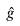Convert formula to latex. <formula><loc_0><loc_0><loc_500><loc_500>\hat { g }</formula> 